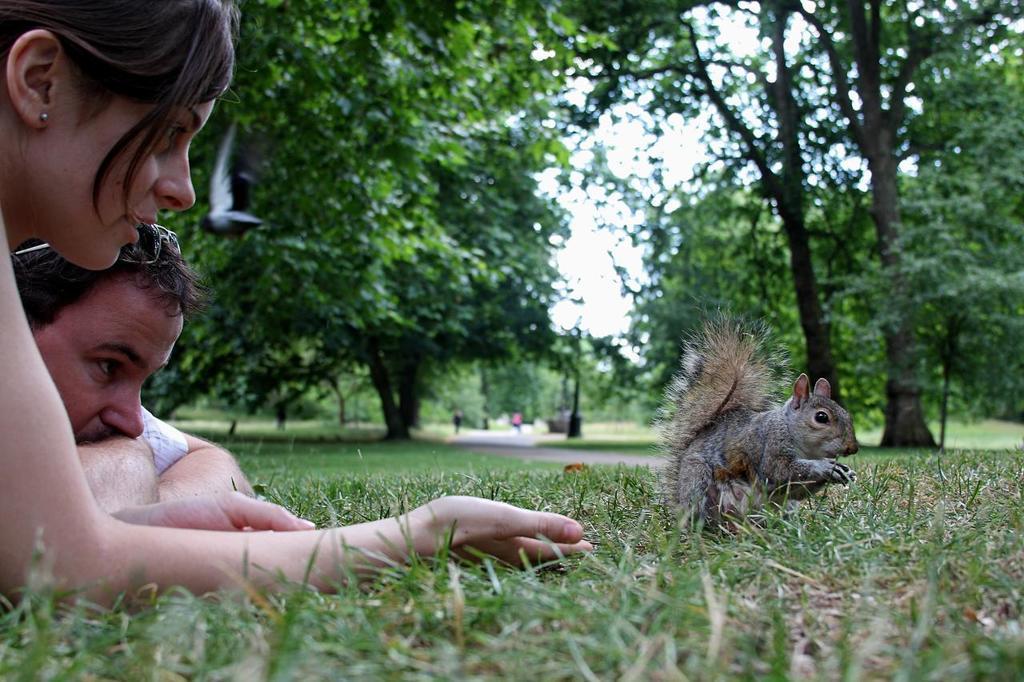Describe this image in one or two sentences. On the left side of the image we can see a man and a lady lying on the grass. In the center there is a squirrel. In the background there are trees and sky. 